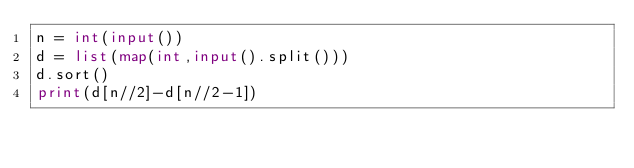Convert code to text. <code><loc_0><loc_0><loc_500><loc_500><_Python_>n = int(input())
d = list(map(int,input().split()))
d.sort()
print(d[n//2]-d[n//2-1])


</code> 